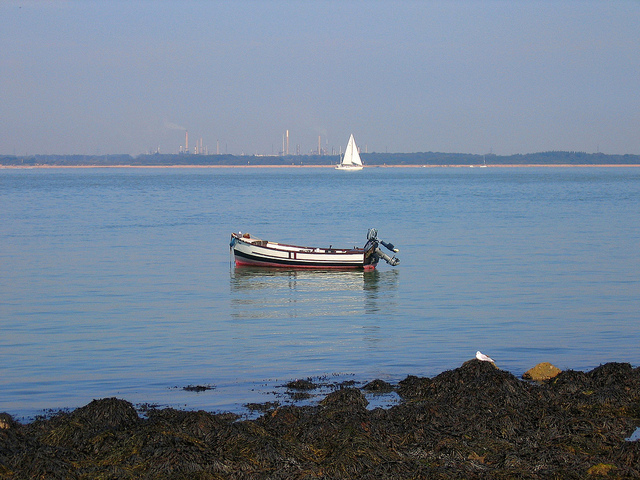What type of boat is close to the shore? The boat that's closest to the shore is a small motorboat, commonly used for nearshore navigation, fishing, or leisure activities. Are there any notable features about this coastal area? The coastal area in the image is tranquil with clear skies and calm waters, ideal for boating or sailing. A noticeable feature is the seaweed covering the rocks, indicating a healthy marine ecosystem. There's also a contrast between the natural serenity and distant industrial structures on the horizon. 